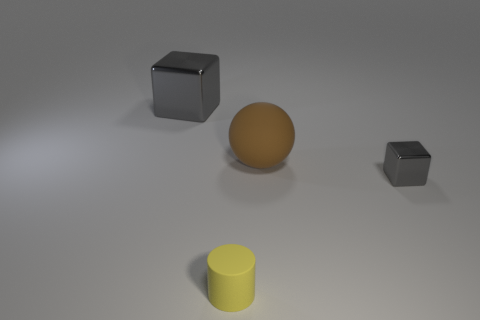Subtract 1 blocks. How many blocks are left? 1 Add 2 small blue shiny things. How many objects exist? 6 Subtract all balls. How many objects are left? 3 Subtract all yellow balls. Subtract all green cylinders. How many balls are left? 1 Subtract all red spheres. How many green cubes are left? 0 Subtract all gray things. Subtract all large gray objects. How many objects are left? 1 Add 1 big balls. How many big balls are left? 2 Add 2 tiny brown metal cylinders. How many tiny brown metal cylinders exist? 2 Subtract 0 purple cylinders. How many objects are left? 4 